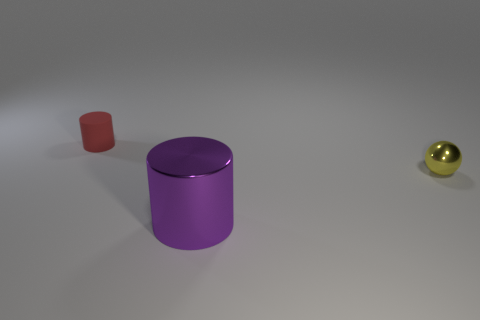What number of small things are yellow metallic things or things?
Your answer should be compact. 2. What is the size of the shiny thing in front of the thing on the right side of the cylinder in front of the small metal thing?
Your response must be concise. Large. There is a cylinder in front of the tiny object on the left side of the tiny metal ball to the right of the large object; what is it made of?
Give a very brief answer. Metal. Is the shape of the rubber object the same as the big purple object?
Your answer should be very brief. Yes. Are there any other things that are made of the same material as the small red thing?
Offer a terse response. No. How many small objects are both on the left side of the tiny yellow object and to the right of the tiny rubber thing?
Provide a succinct answer. 0. The thing that is to the left of the cylinder right of the red matte thing is what color?
Give a very brief answer. Red. Are there the same number of tiny yellow metallic spheres left of the purple metallic cylinder and big purple metallic objects?
Offer a very short reply. No. How many rubber things are behind the tiny thing that is to the left of the thing that is in front of the yellow ball?
Keep it short and to the point. 0. There is a cylinder that is in front of the small red matte object; what is its color?
Make the answer very short. Purple. 